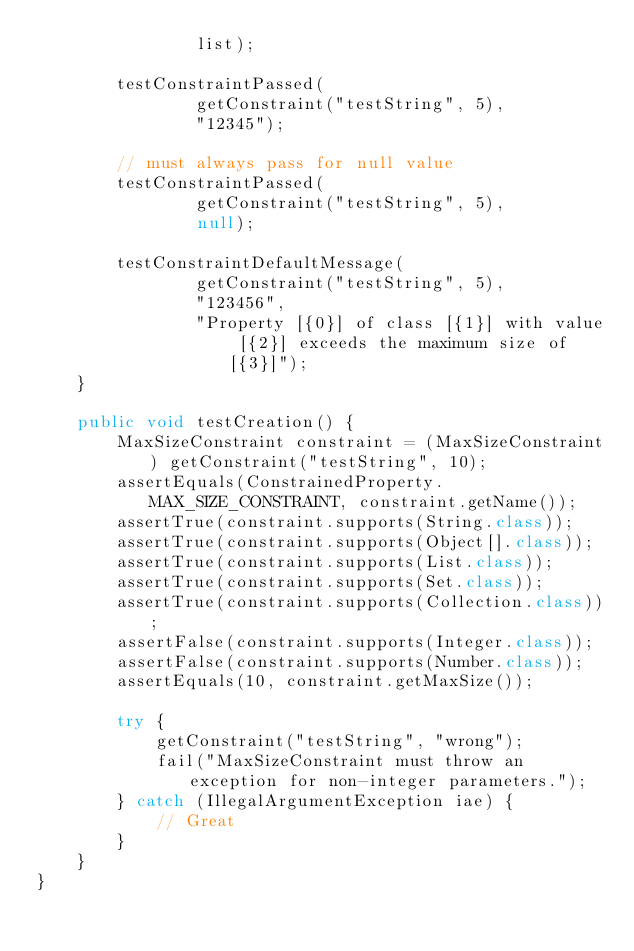Convert code to text. <code><loc_0><loc_0><loc_500><loc_500><_Java_>                list);

        testConstraintPassed(
                getConstraint("testString", 5),
                "12345");

        // must always pass for null value
        testConstraintPassed(
                getConstraint("testString", 5),
                null);

        testConstraintDefaultMessage(
                getConstraint("testString", 5),
                "123456",
                "Property [{0}] of class [{1}] with value [{2}] exceeds the maximum size of [{3}]");
    }

    public void testCreation() {
        MaxSizeConstraint constraint = (MaxSizeConstraint) getConstraint("testString", 10);
        assertEquals(ConstrainedProperty.MAX_SIZE_CONSTRAINT, constraint.getName());
        assertTrue(constraint.supports(String.class));
        assertTrue(constraint.supports(Object[].class));
        assertTrue(constraint.supports(List.class));
        assertTrue(constraint.supports(Set.class));
        assertTrue(constraint.supports(Collection.class));
        assertFalse(constraint.supports(Integer.class));
        assertFalse(constraint.supports(Number.class));
        assertEquals(10, constraint.getMaxSize());

        try {
            getConstraint("testString", "wrong");
            fail("MaxSizeConstraint must throw an exception for non-integer parameters.");
        } catch (IllegalArgumentException iae) {
            // Great
        }
    }
}
</code> 